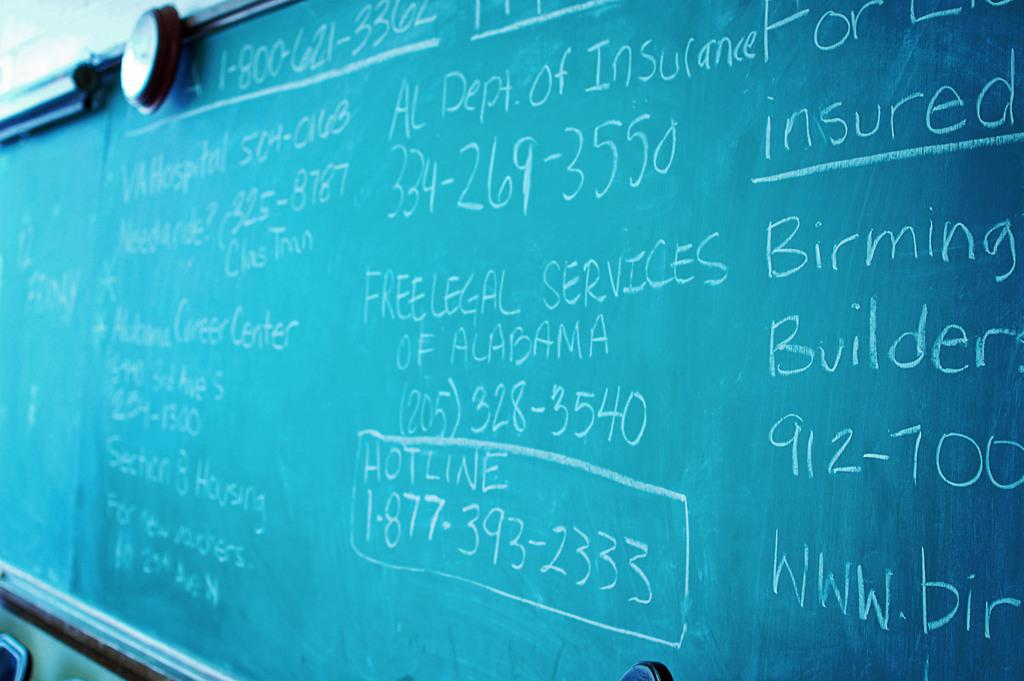<image>
Give a short and clear explanation of the subsequent image. A chalkboard with info such as Free Legal Services of Alabama. 